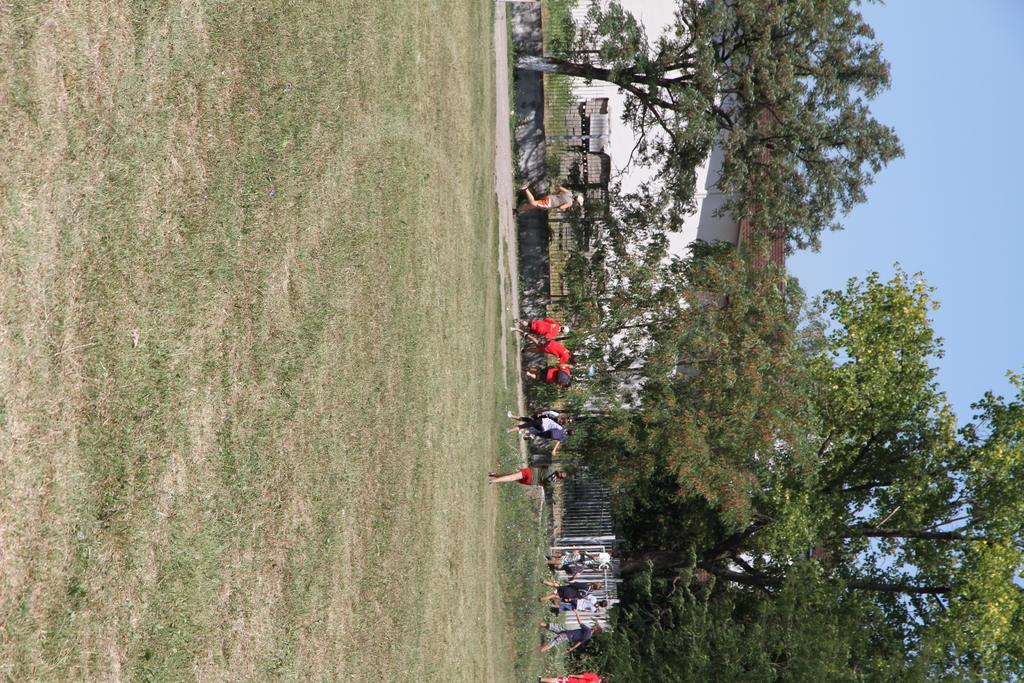In one or two sentences, can you explain what this image depicts? This picture describes about group of people, few people are walking and few are running, in the background we can see fence, trees and a house. 